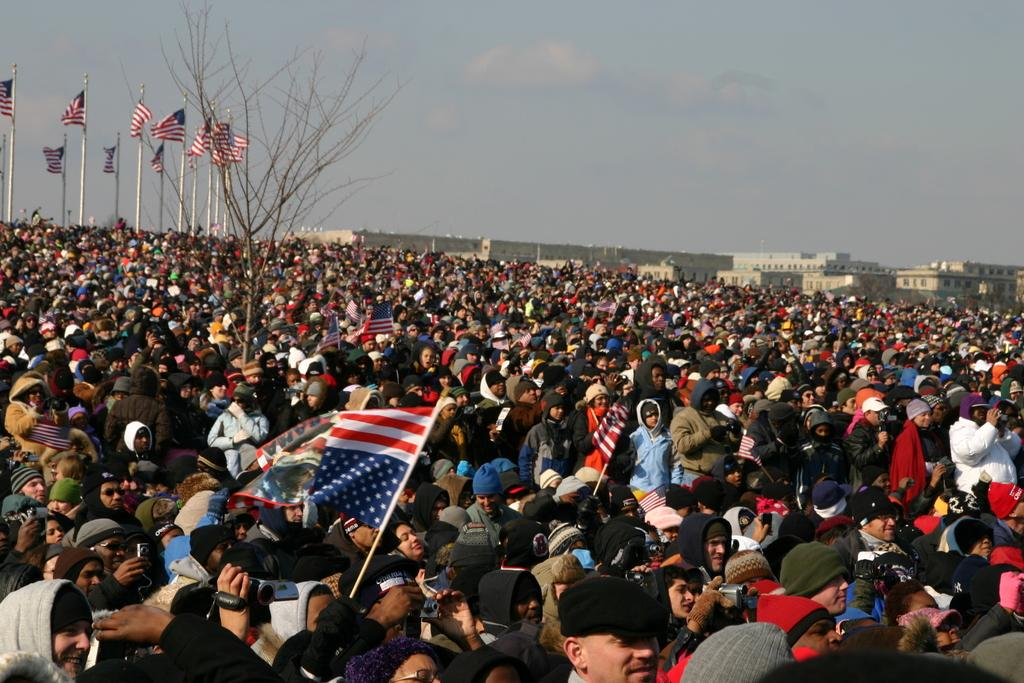What type of structures can be seen in the image? There are buildings in the image. Who or what else is present in the image? There are people and a tree in the image. What other objects can be seen in the image? There are flags and poles in the image. What can be seen in the background of the image? The sky is visible in the image. Where is the key located in the image? There is no key present in the image. What type of market can be seen in the image? There is no market present in the image. 